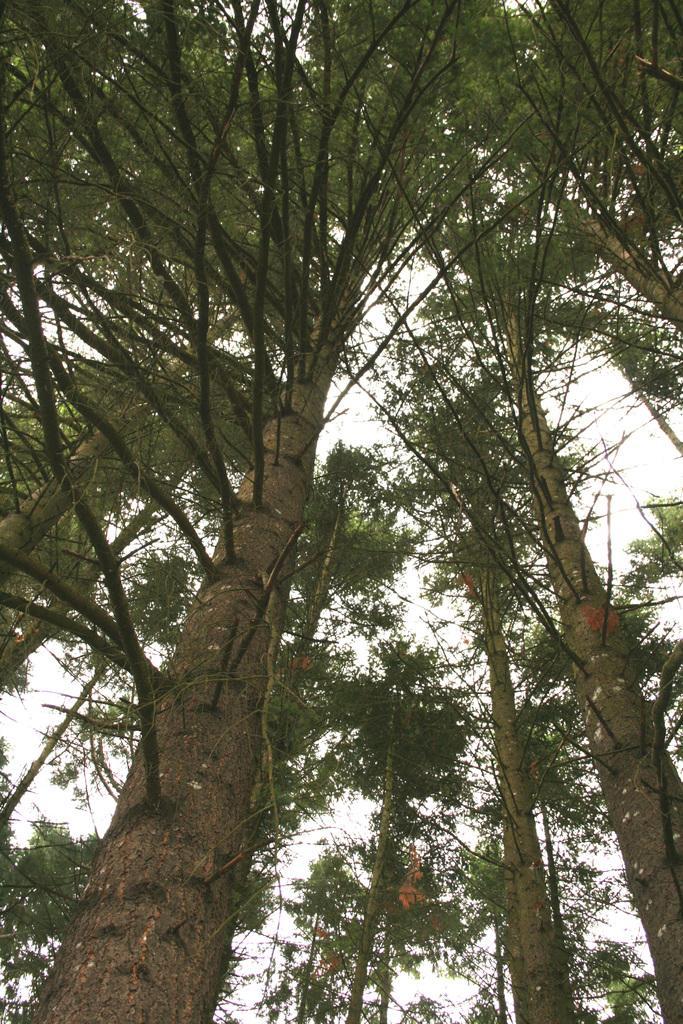Please provide a concise description of this image. In this image I can see number of trees. 